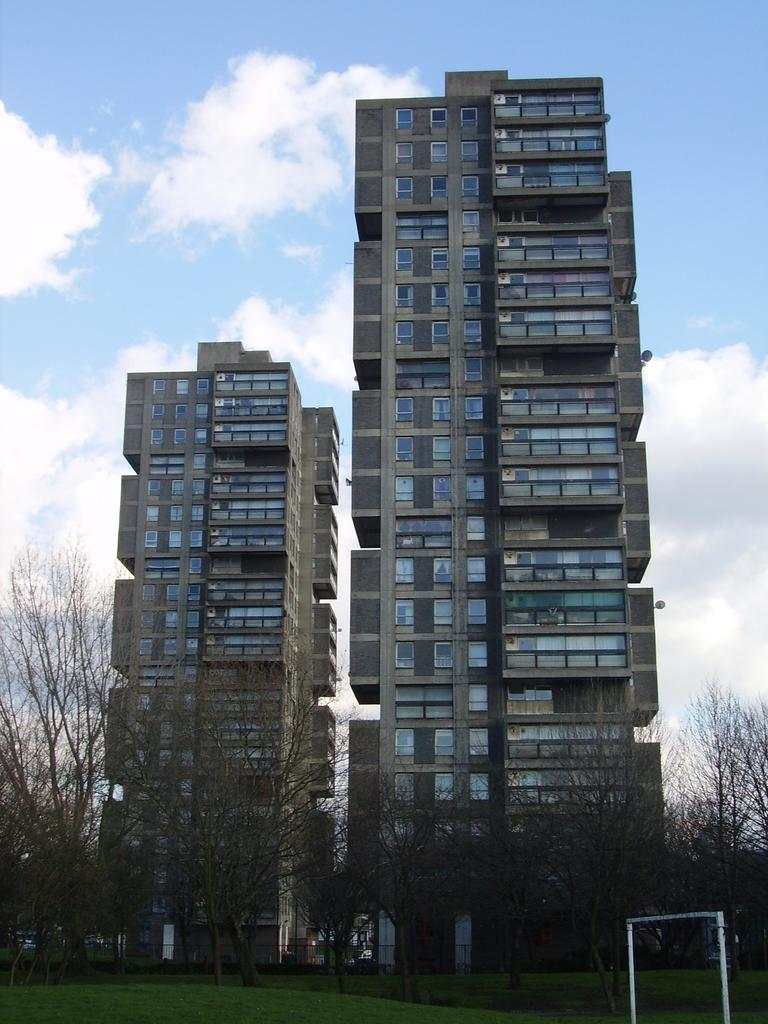What type of structures can be seen in the image? There are buildings in the image. What type of vegetation is present in the image? There are trees and grass in the image. What is the color of the object on the ground? The object on the ground is white. What is visible in the background of the image? The sky is visible in the background of the image. How many quarters are being used as a tray in the image? There are no quarters or trays present in the image. Is there a baby crawling on the grass in the image? There is no baby visible in the image; it only features buildings, trees, grass, a white object, and the sky. 